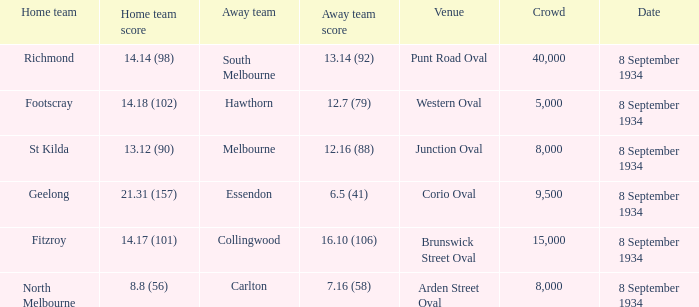What was the away team's score when the home team achieved 14.14 (98)? 13.14 (92). 